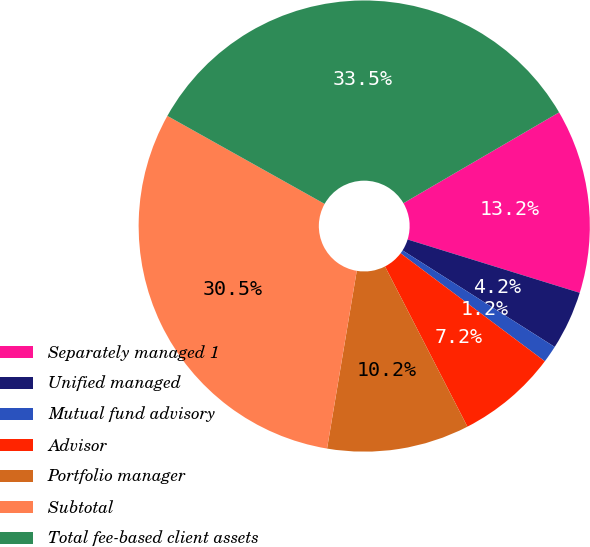<chart> <loc_0><loc_0><loc_500><loc_500><pie_chart><fcel>Separately managed 1<fcel>Unified managed<fcel>Mutual fund advisory<fcel>Advisor<fcel>Portfolio manager<fcel>Subtotal<fcel>Total fee-based client assets<nl><fcel>13.19%<fcel>4.22%<fcel>1.23%<fcel>7.21%<fcel>10.2%<fcel>30.49%<fcel>33.48%<nl></chart> 